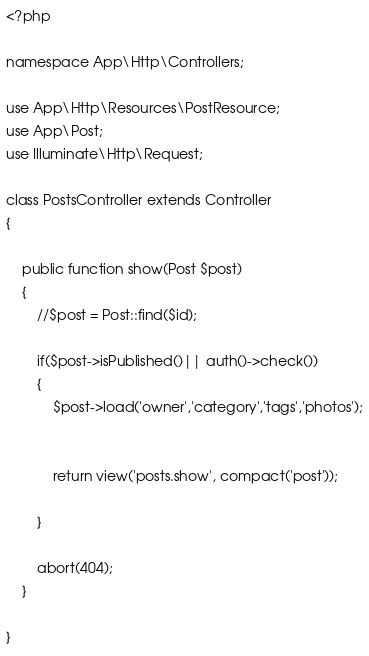<code> <loc_0><loc_0><loc_500><loc_500><_PHP_><?php

namespace App\Http\Controllers;

use App\Http\Resources\PostResource;
use App\Post;
use Illuminate\Http\Request;

class PostsController extends Controller
{

    public function show(Post $post)
    {
        //$post = Post::find($id);

        if($post->isPublished()|| auth()->check())
        {
            $post->load('owner','category','tags','photos');


            return view('posts.show', compact('post'));

        }

        abort(404);
    }

}
</code> 